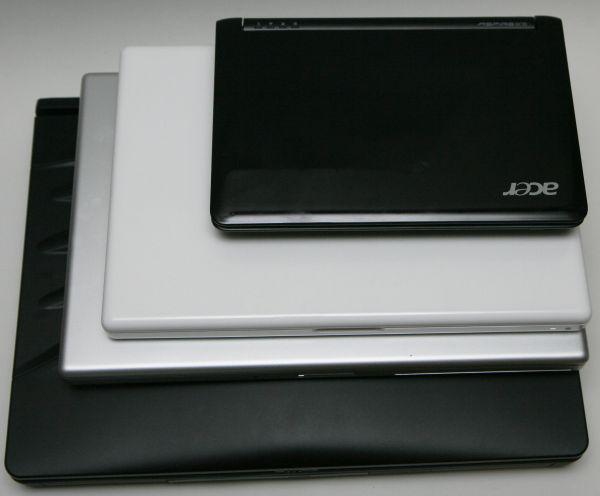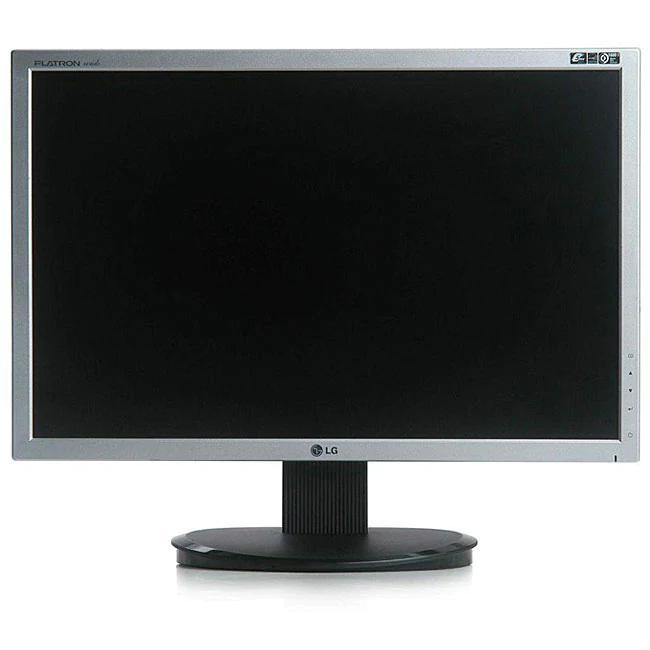The first image is the image on the left, the second image is the image on the right. Assess this claim about the two images: "One image shows side by side open laptops, and the other shows a small laptop resting on top of a bigger one.". Correct or not? Answer yes or no. No. The first image is the image on the left, the second image is the image on the right. For the images displayed, is the sentence "Exactly two open laptops can be seen on the image on the right." factually correct? Answer yes or no. No. 